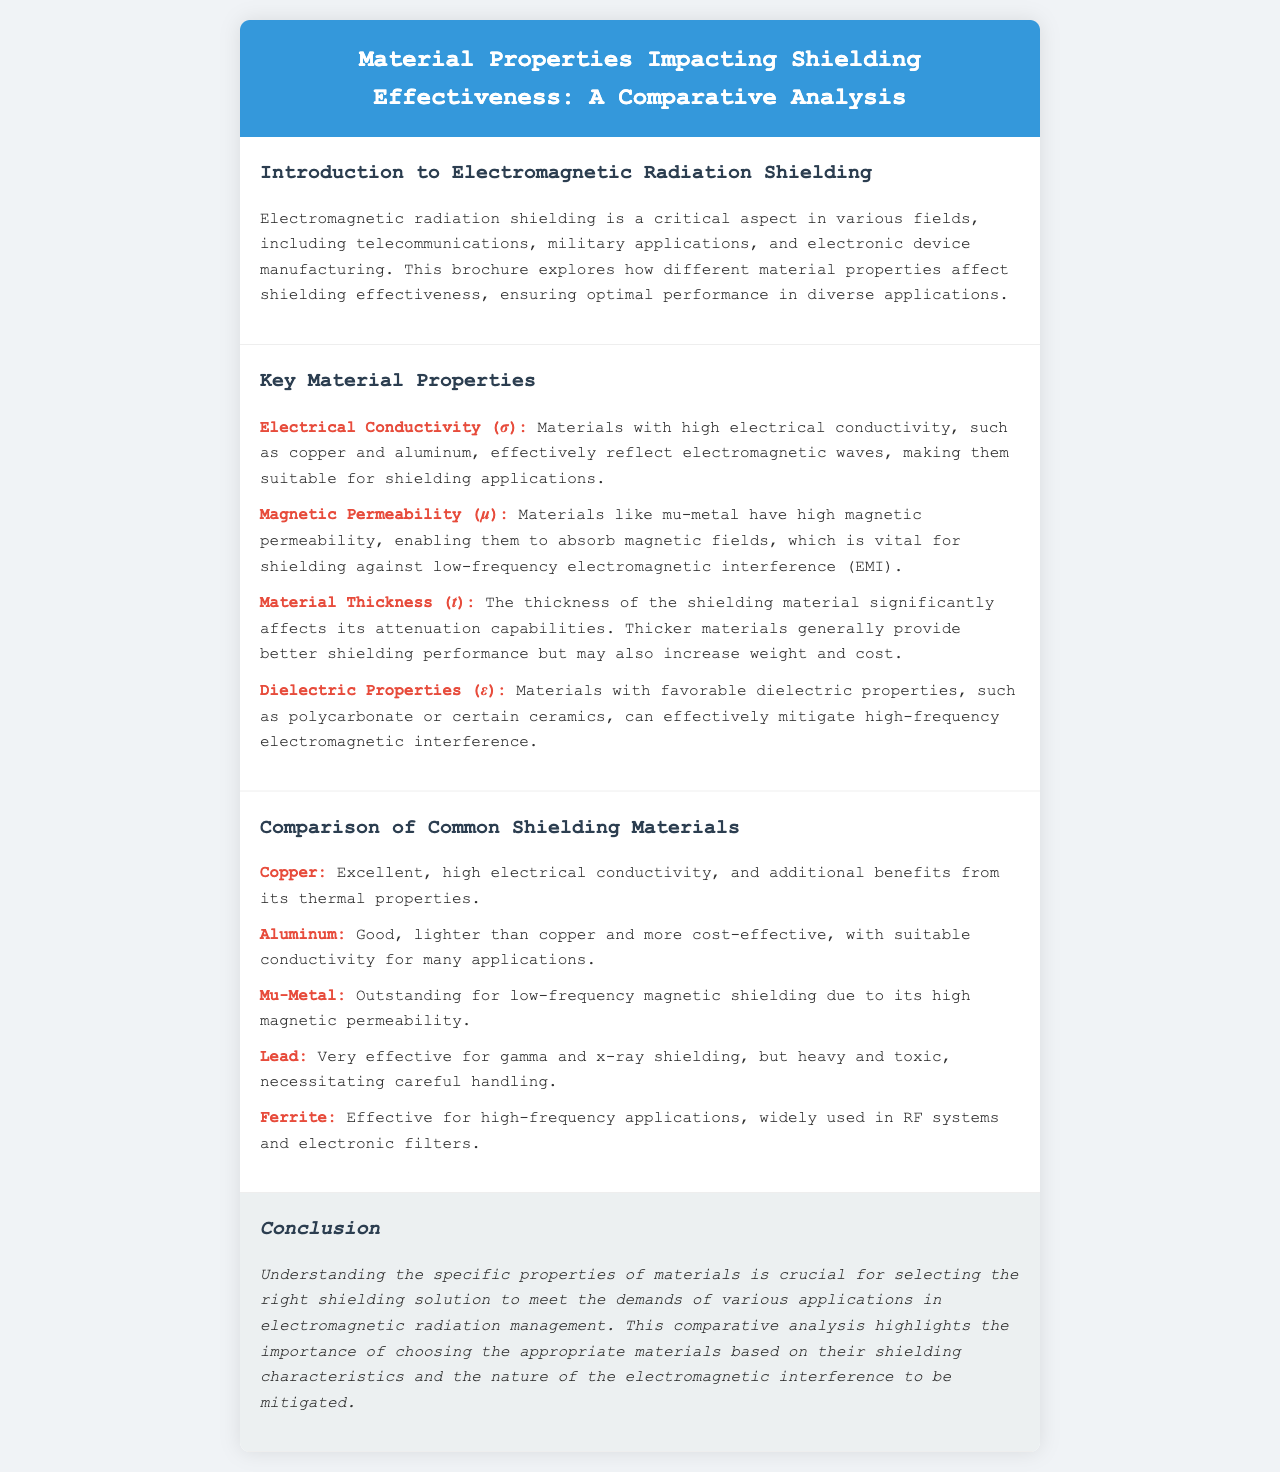What is the title of the brochure? The title of the brochure is stated in the header section, which provides the main subject matter.
Answer: Material Properties Impacting Shielding Effectiveness: A Comparative Analysis What material is mentioned for its high electrical conductivity? The document lists copper and aluminum as materials with high electrical conductivity.
Answer: Copper What property is represented by the symbol σ? The document explicitly defines the symbol σ as electrical conductivity in the context of material properties impacting shielding effectiveness.
Answer: Electrical Conductivity Which material is noted for outstanding low-frequency magnetic shielding? The document compares various materials for their shielding effectiveness and identifies mu-metal for its capabilities.
Answer: Mu-Metal How does material thickness impact shielding performance? The brochure discusses the relationship between material thickness and attenuation capabilities, emphasizing its significance.
Answer: Better shielding performance What are two properties of lead mentioned in the document? The document highlights that lead is very effective for gamma and x-ray shielding while also noting its weight and toxicity.
Answer: Heavy and toxic What dielectric materials are specified in the brochure? The brochure lists examples of favorable dielectric materials relevant to electromagnetic interference mitigation.
Answer: Polycarbonate and certain ceramics What is the main focus of the conclusion section? The conclusion summarizes the importance of selecting appropriate materials based on their shielding characteristics and interference nature.
Answer: Selecting the right shielding solution 